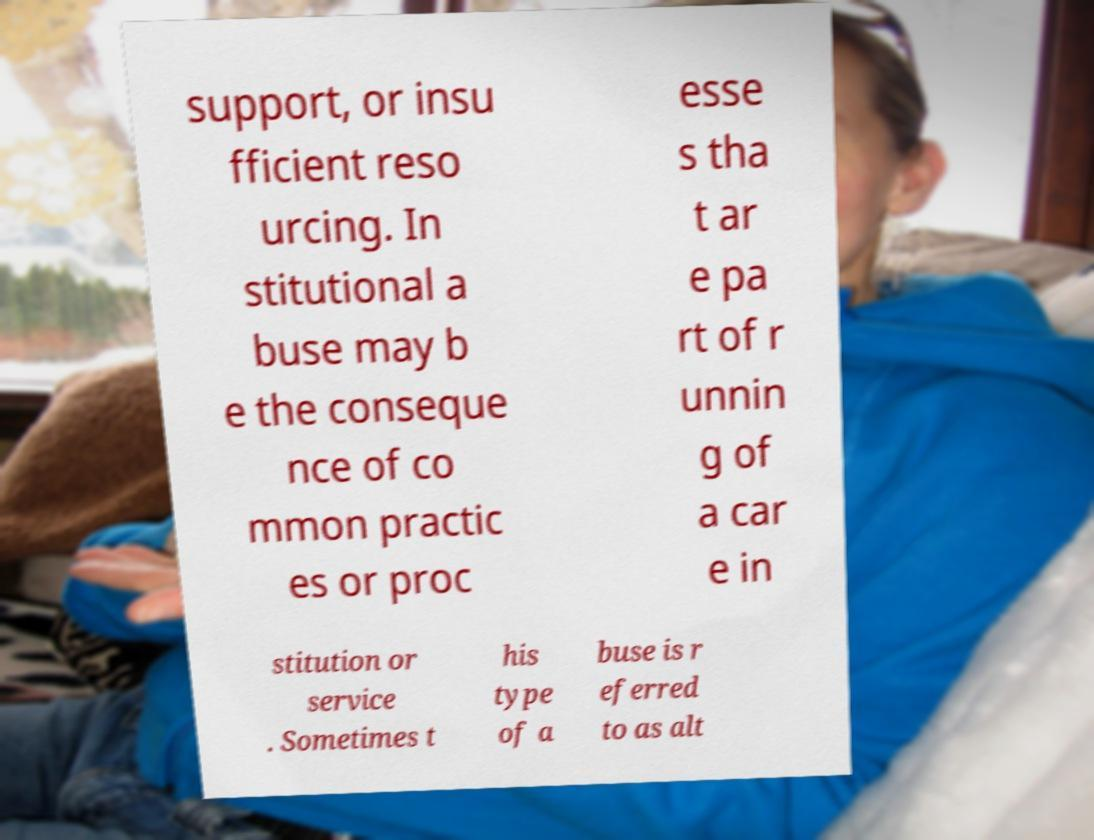There's text embedded in this image that I need extracted. Can you transcribe it verbatim? support, or insu fficient reso urcing. In stitutional a buse may b e the conseque nce of co mmon practic es or proc esse s tha t ar e pa rt of r unnin g of a car e in stitution or service . Sometimes t his type of a buse is r eferred to as alt 